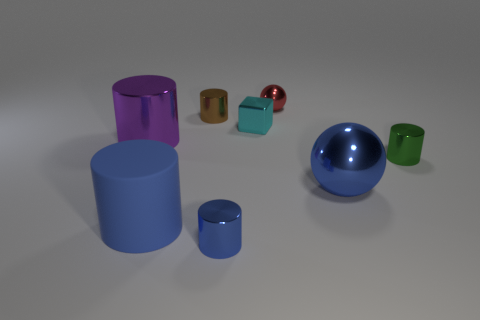What number of brown objects are either shiny cylinders or matte things?
Make the answer very short. 1. Are there any green metallic cylinders in front of the small cyan metal object?
Offer a very short reply. Yes. Is the shape of the big metallic thing that is in front of the large metallic cylinder the same as the object that is behind the tiny brown metal thing?
Make the answer very short. Yes. There is a large blue thing that is the same shape as the brown metal object; what material is it?
Make the answer very short. Rubber. How many cylinders are either blue matte objects or red metal objects?
Provide a short and direct response. 1. What number of small purple balls have the same material as the small brown cylinder?
Give a very brief answer. 0. Does the tiny cylinder behind the large metallic cylinder have the same material as the large thing in front of the big blue metal ball?
Make the answer very short. No. There is a tiny shiny cylinder on the right side of the blue shiny thing on the left side of the small metallic ball; how many big shiny spheres are to the left of it?
Provide a succinct answer. 1. Do the large object to the right of the brown shiny cylinder and the tiny thing in front of the rubber thing have the same color?
Give a very brief answer. Yes. Are there any other things of the same color as the small sphere?
Your answer should be compact. No. 